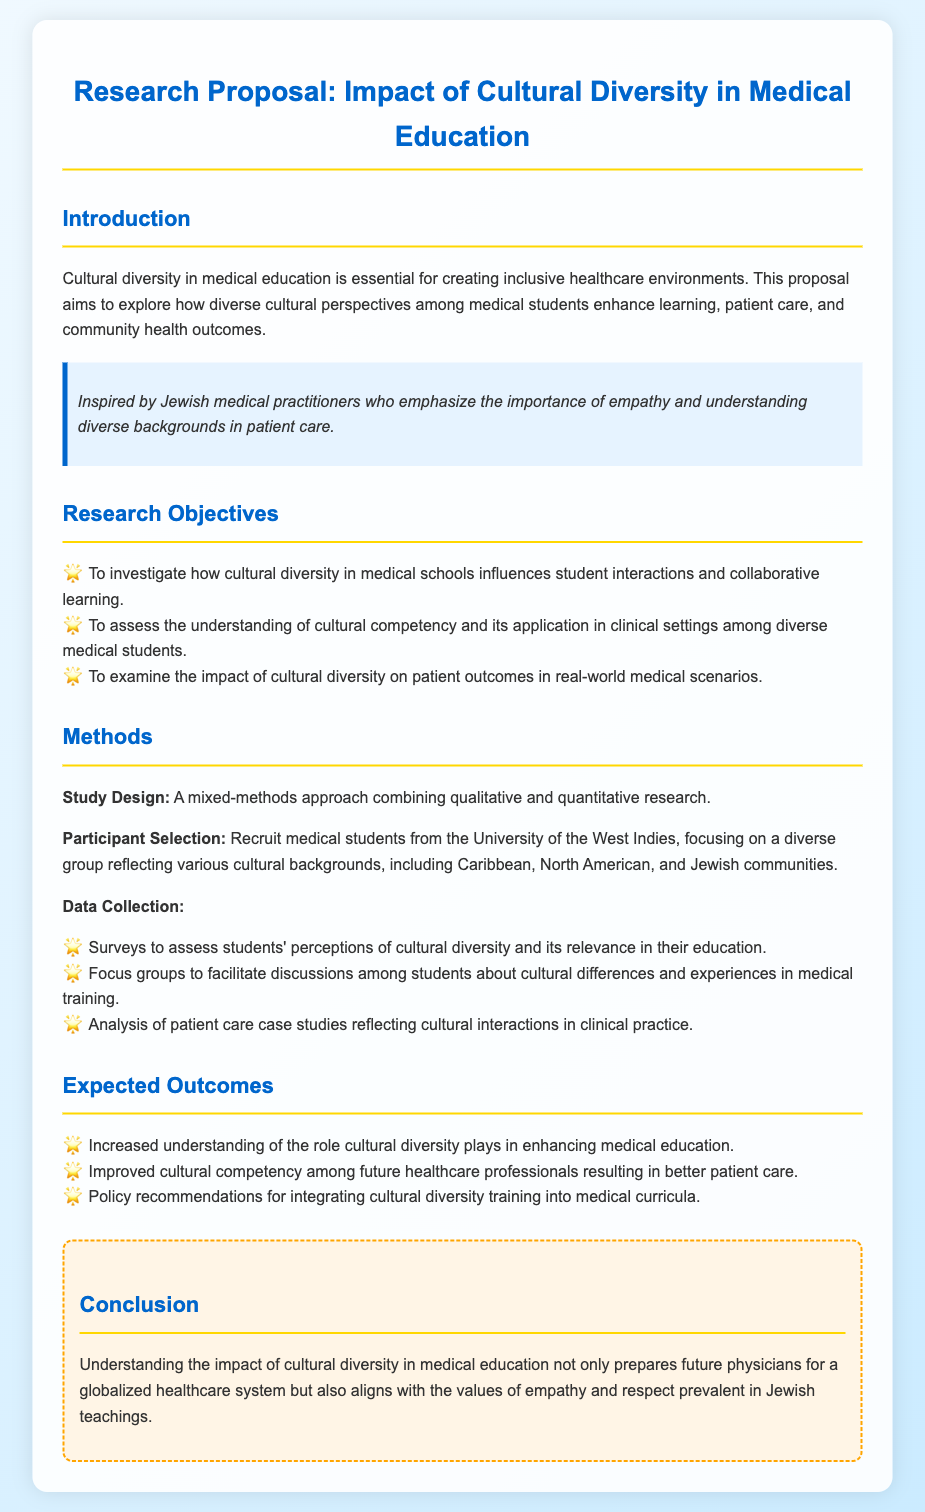What is the title of the research proposal? The title is the main heading of the document, summarizing its focus.
Answer: Impact of Cultural Diversity in Medical Education What is the first research objective? The first objective is outlined in a bullet point under research objectives in the proposal.
Answer: To investigate how cultural diversity in medical schools influences student interactions and collaborative learning Which university's medical students are being recruited for the study? The university mentioned in the participant selection section provides the focus for recruitment.
Answer: University of the West Indies What data collection method involves discussing cultural differences? This method is specifically aimed at gathering qualitative insights from students.
Answer: Focus groups What is an expected outcome of the research? An expected outcome is discussed under the section detailing the results the research aims to achieve.
Answer: Increased understanding of the role cultural diversity plays in enhancing medical education What style is the inspirational quote formatted in? The style signifies a personal motivation or reflection within the document context.
Answer: Italic How does the conclusion relate to Jewish teachings? The conclusion connects the research findings back to values emphasized within Jewish culture.
Answer: Empathy and respect 